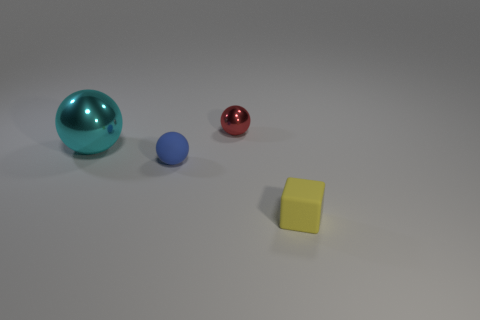Subtract all tiny blue rubber balls. How many balls are left? 2 Add 1 big things. How many objects exist? 5 Subtract all blue balls. How many balls are left? 2 Subtract all balls. How many objects are left? 1 Subtract all green blocks. Subtract all blue cylinders. How many blocks are left? 1 Subtract all cyan cubes. How many red balls are left? 1 Subtract all blue matte spheres. Subtract all small red metallic spheres. How many objects are left? 2 Add 3 cyan spheres. How many cyan spheres are left? 4 Add 3 small yellow things. How many small yellow things exist? 4 Subtract 0 blue cylinders. How many objects are left? 4 